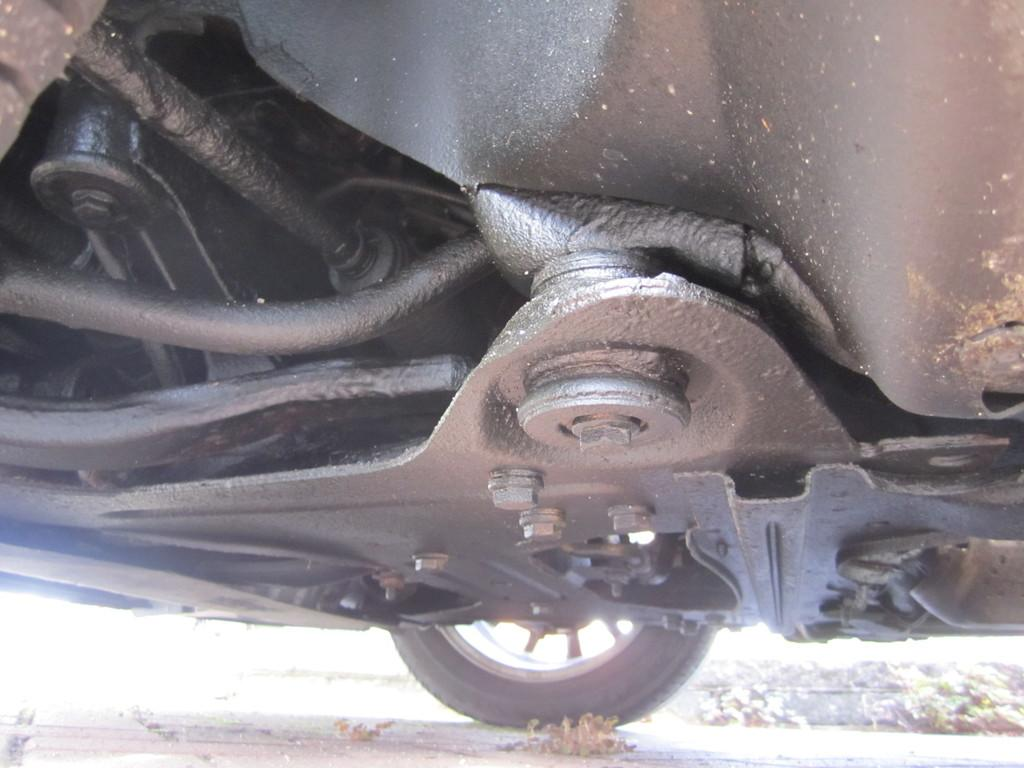What type of object is in the foreground of the image? There are parts of a vehicle in the foreground of the image. What type of fasteners can be seen in the image? Screws and nuts are visible in the image. What type of component can be seen in the image? There is a piston visible in the image. What type of wheel is visible in the image? There is a wheel visible in the image. What type of apple is being used to build the vehicle in the image? There is no apple present in the image; it features parts of a vehicle, screws, nuts, a piston, and a wheel. How does the snow affect the functioning of the vehicle in the image? There is no snow present in the image; it is focused on vehicle parts and components. 